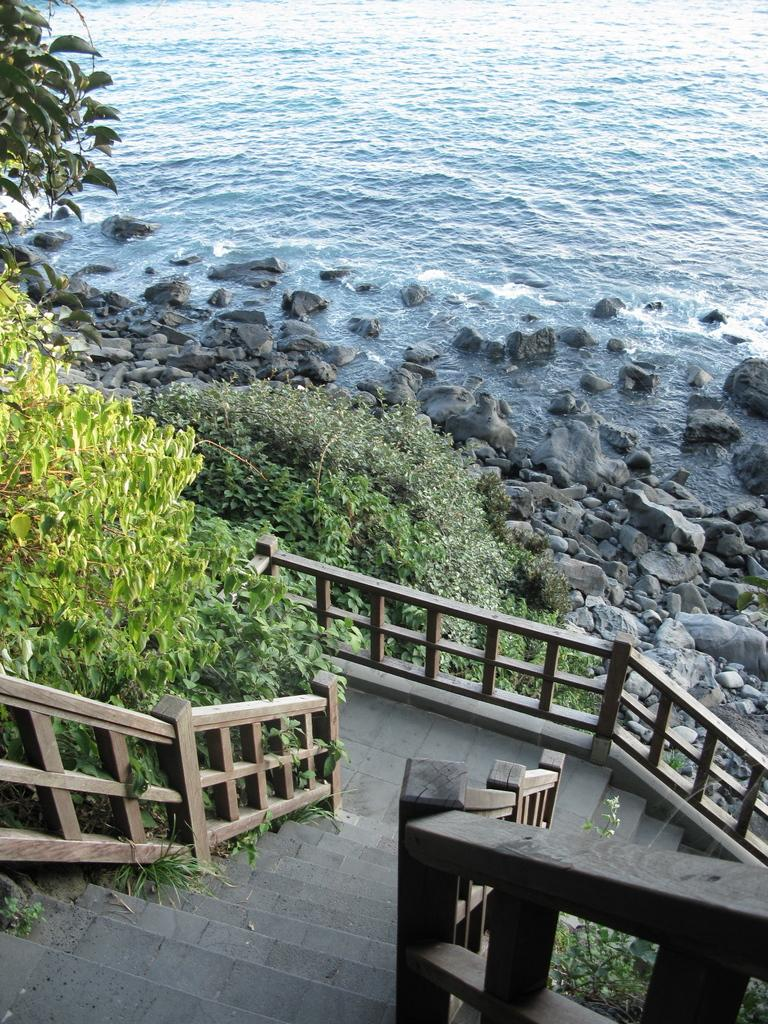What type of structure is present in the image? There are stairs in the image. What material is used for the railing on the stairs? The stairs have a wooden railing. What type of vegetation can be seen in the image? There are trees in the image. What type of ground surface is visible in the image? There are stones in the image. What natural element is visible in the image? There is water visible in the image. What type of chess piece is located at the top of the stairs in the image? There is no chess piece present in the image; it only features stairs, a wooden railing, trees, stones, and water. 